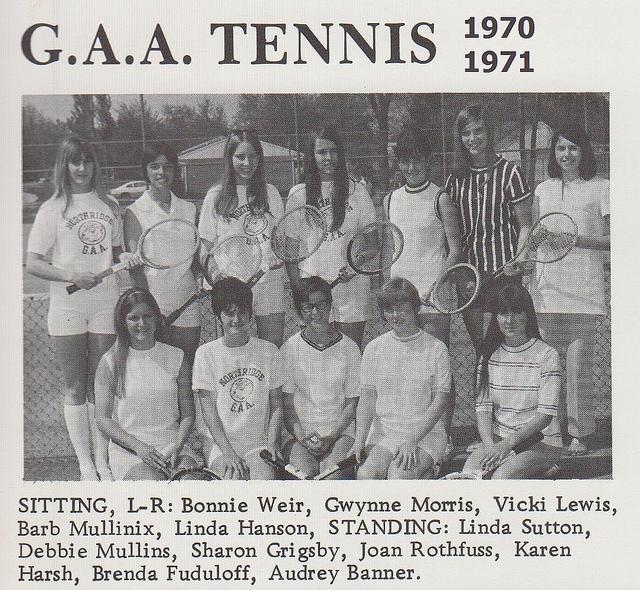Are they all wearing hats?
Be succinct. No. What sport is this?
Short answer required. Tennis. What year was this taken?
Quick response, please. 1971. Is this a co-ed team?
Short answer required. No. What date is posted on the ad?
Concise answer only. 1970 and 1971. What are they advertising?
Quick response, please. Tennis. 